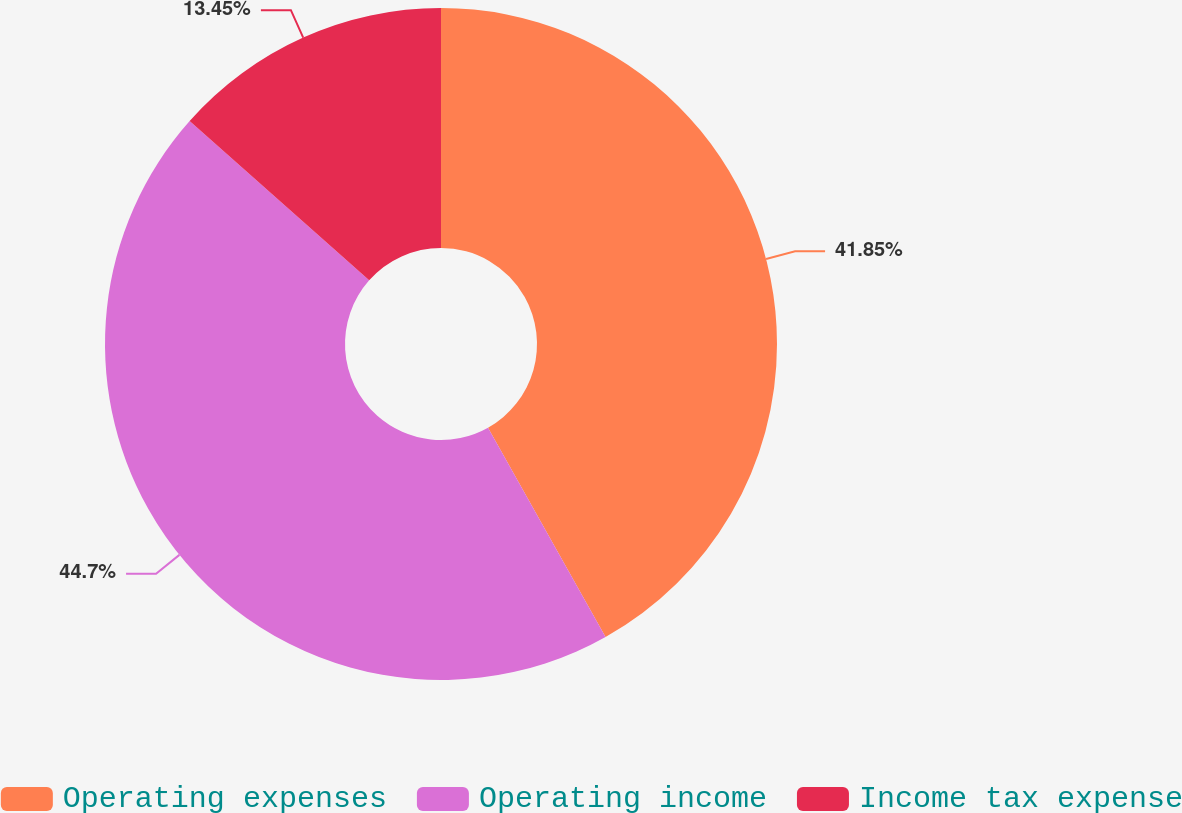Convert chart to OTSL. <chart><loc_0><loc_0><loc_500><loc_500><pie_chart><fcel>Operating expenses<fcel>Operating income<fcel>Income tax expense<nl><fcel>41.85%<fcel>44.69%<fcel>13.45%<nl></chart> 